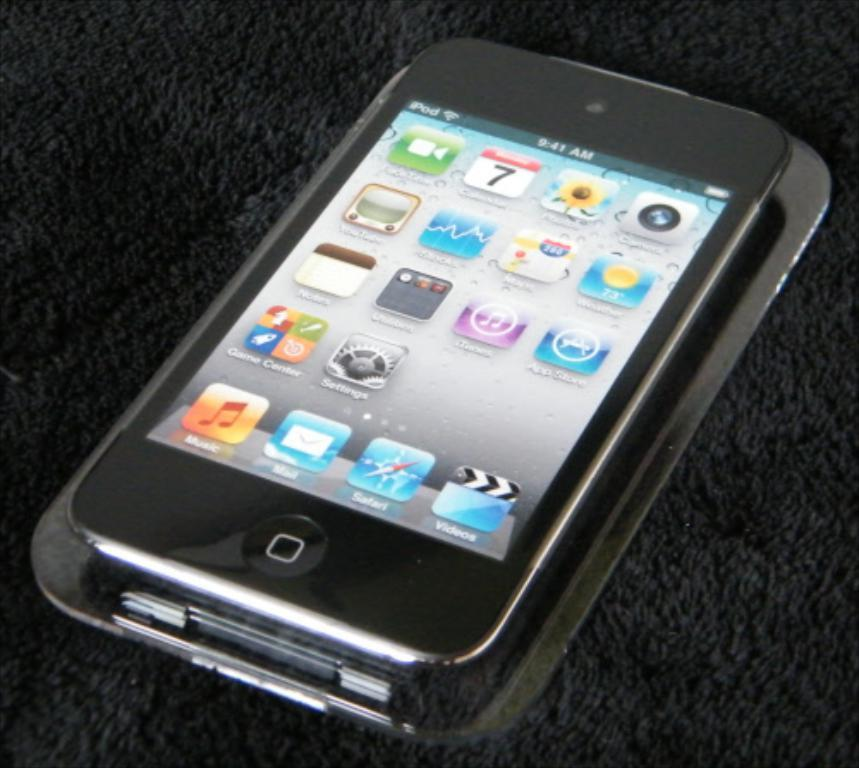Provide a one-sentence caption for the provided image. a cell phone with the time 9:41 AM shown on the display. 